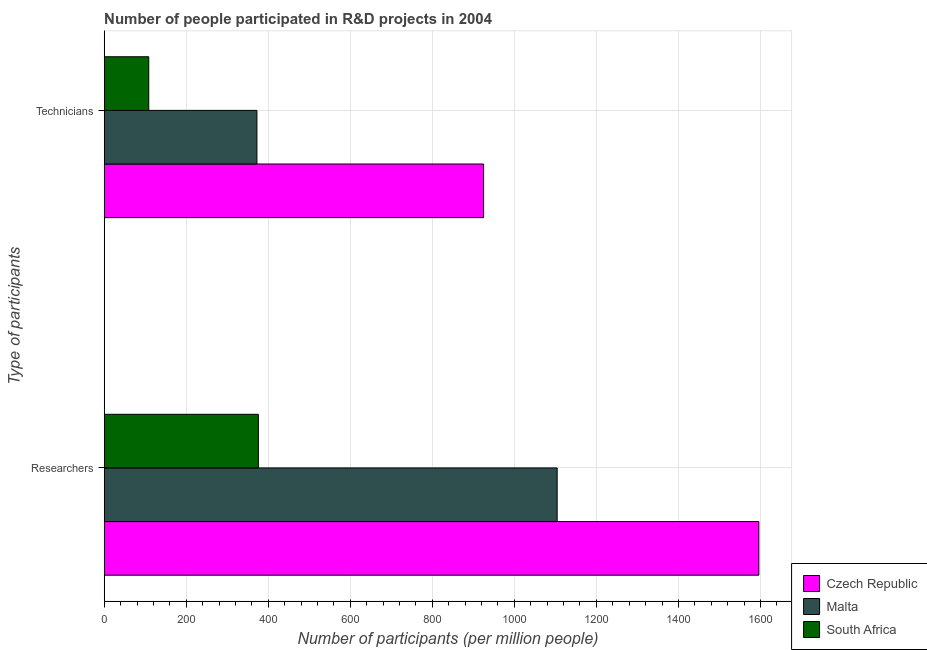How many groups of bars are there?
Ensure brevity in your answer.  2. Are the number of bars per tick equal to the number of legend labels?
Offer a very short reply. Yes. How many bars are there on the 2nd tick from the top?
Your answer should be compact. 3. How many bars are there on the 1st tick from the bottom?
Give a very brief answer. 3. What is the label of the 1st group of bars from the top?
Provide a short and direct response. Technicians. What is the number of technicians in Czech Republic?
Your answer should be compact. 924.94. Across all countries, what is the maximum number of researchers?
Your response must be concise. 1596.12. Across all countries, what is the minimum number of researchers?
Keep it short and to the point. 375.83. In which country was the number of researchers maximum?
Provide a succinct answer. Czech Republic. In which country was the number of researchers minimum?
Your answer should be compact. South Africa. What is the total number of technicians in the graph?
Make the answer very short. 1405.87. What is the difference between the number of researchers in Malta and that in Czech Republic?
Your answer should be very brief. -491.72. What is the difference between the number of technicians in Czech Republic and the number of researchers in South Africa?
Give a very brief answer. 549.11. What is the average number of researchers per country?
Provide a short and direct response. 1025.45. What is the difference between the number of technicians and number of researchers in South Africa?
Keep it short and to the point. -267.25. What is the ratio of the number of researchers in Czech Republic to that in Malta?
Make the answer very short. 1.45. Is the number of researchers in Czech Republic less than that in South Africa?
Offer a terse response. No. What does the 3rd bar from the top in Technicians represents?
Your response must be concise. Czech Republic. What does the 3rd bar from the bottom in Researchers represents?
Make the answer very short. South Africa. How many bars are there?
Your response must be concise. 6. Are all the bars in the graph horizontal?
Your answer should be compact. Yes. How many countries are there in the graph?
Provide a succinct answer. 3. What is the difference between two consecutive major ticks on the X-axis?
Your answer should be very brief. 200. Does the graph contain any zero values?
Give a very brief answer. No. Does the graph contain grids?
Your answer should be compact. Yes. How are the legend labels stacked?
Provide a succinct answer. Vertical. What is the title of the graph?
Offer a very short reply. Number of people participated in R&D projects in 2004. What is the label or title of the X-axis?
Your answer should be very brief. Number of participants (per million people). What is the label or title of the Y-axis?
Your response must be concise. Type of participants. What is the Number of participants (per million people) of Czech Republic in Researchers?
Offer a terse response. 1596.12. What is the Number of participants (per million people) in Malta in Researchers?
Provide a succinct answer. 1104.4. What is the Number of participants (per million people) of South Africa in Researchers?
Provide a short and direct response. 375.83. What is the Number of participants (per million people) in Czech Republic in Technicians?
Keep it short and to the point. 924.94. What is the Number of participants (per million people) of Malta in Technicians?
Your response must be concise. 372.35. What is the Number of participants (per million people) in South Africa in Technicians?
Offer a very short reply. 108.58. Across all Type of participants, what is the maximum Number of participants (per million people) in Czech Republic?
Make the answer very short. 1596.12. Across all Type of participants, what is the maximum Number of participants (per million people) in Malta?
Provide a succinct answer. 1104.4. Across all Type of participants, what is the maximum Number of participants (per million people) of South Africa?
Your answer should be very brief. 375.83. Across all Type of participants, what is the minimum Number of participants (per million people) in Czech Republic?
Give a very brief answer. 924.94. Across all Type of participants, what is the minimum Number of participants (per million people) in Malta?
Offer a terse response. 372.35. Across all Type of participants, what is the minimum Number of participants (per million people) in South Africa?
Keep it short and to the point. 108.58. What is the total Number of participants (per million people) in Czech Republic in the graph?
Provide a succinct answer. 2521.05. What is the total Number of participants (per million people) in Malta in the graph?
Give a very brief answer. 1476.75. What is the total Number of participants (per million people) in South Africa in the graph?
Provide a short and direct response. 484.41. What is the difference between the Number of participants (per million people) of Czech Republic in Researchers and that in Technicians?
Offer a very short reply. 671.18. What is the difference between the Number of participants (per million people) in Malta in Researchers and that in Technicians?
Keep it short and to the point. 732.04. What is the difference between the Number of participants (per million people) of South Africa in Researchers and that in Technicians?
Your answer should be very brief. 267.25. What is the difference between the Number of participants (per million people) of Czech Republic in Researchers and the Number of participants (per million people) of Malta in Technicians?
Offer a very short reply. 1223.76. What is the difference between the Number of participants (per million people) in Czech Republic in Researchers and the Number of participants (per million people) in South Africa in Technicians?
Provide a short and direct response. 1487.54. What is the difference between the Number of participants (per million people) in Malta in Researchers and the Number of participants (per million people) in South Africa in Technicians?
Offer a terse response. 995.82. What is the average Number of participants (per million people) in Czech Republic per Type of participants?
Make the answer very short. 1260.53. What is the average Number of participants (per million people) of Malta per Type of participants?
Ensure brevity in your answer.  738.37. What is the average Number of participants (per million people) of South Africa per Type of participants?
Keep it short and to the point. 242.2. What is the difference between the Number of participants (per million people) of Czech Republic and Number of participants (per million people) of Malta in Researchers?
Your answer should be compact. 491.72. What is the difference between the Number of participants (per million people) of Czech Republic and Number of participants (per million people) of South Africa in Researchers?
Make the answer very short. 1220.29. What is the difference between the Number of participants (per million people) in Malta and Number of participants (per million people) in South Africa in Researchers?
Your answer should be very brief. 728.57. What is the difference between the Number of participants (per million people) of Czech Republic and Number of participants (per million people) of Malta in Technicians?
Your response must be concise. 552.58. What is the difference between the Number of participants (per million people) of Czech Republic and Number of participants (per million people) of South Africa in Technicians?
Make the answer very short. 816.36. What is the difference between the Number of participants (per million people) in Malta and Number of participants (per million people) in South Africa in Technicians?
Your response must be concise. 263.77. What is the ratio of the Number of participants (per million people) of Czech Republic in Researchers to that in Technicians?
Offer a very short reply. 1.73. What is the ratio of the Number of participants (per million people) of Malta in Researchers to that in Technicians?
Offer a terse response. 2.97. What is the ratio of the Number of participants (per million people) in South Africa in Researchers to that in Technicians?
Keep it short and to the point. 3.46. What is the difference between the highest and the second highest Number of participants (per million people) in Czech Republic?
Offer a very short reply. 671.18. What is the difference between the highest and the second highest Number of participants (per million people) of Malta?
Your answer should be very brief. 732.04. What is the difference between the highest and the second highest Number of participants (per million people) in South Africa?
Give a very brief answer. 267.25. What is the difference between the highest and the lowest Number of participants (per million people) in Czech Republic?
Make the answer very short. 671.18. What is the difference between the highest and the lowest Number of participants (per million people) in Malta?
Your answer should be compact. 732.04. What is the difference between the highest and the lowest Number of participants (per million people) of South Africa?
Provide a short and direct response. 267.25. 